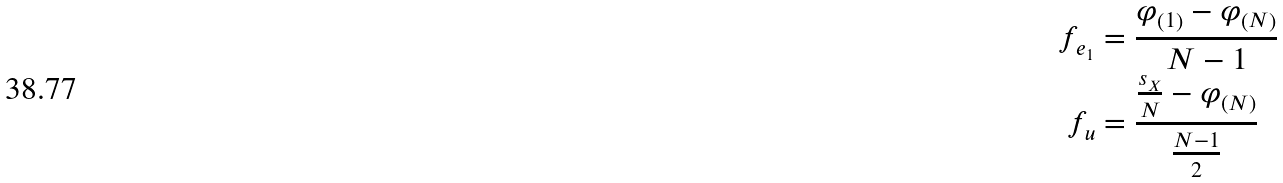Convert formula to latex. <formula><loc_0><loc_0><loc_500><loc_500>f _ { e _ { 1 } } & = \frac { \varphi _ { \left ( 1 \right ) } - \varphi _ { \left ( N \right ) } } { N - 1 } \\ f _ { u } & = \frac { \frac { s _ { X } } { N } - \varphi _ { \left ( N \right ) } } { \frac { N - 1 } { 2 } }</formula> 